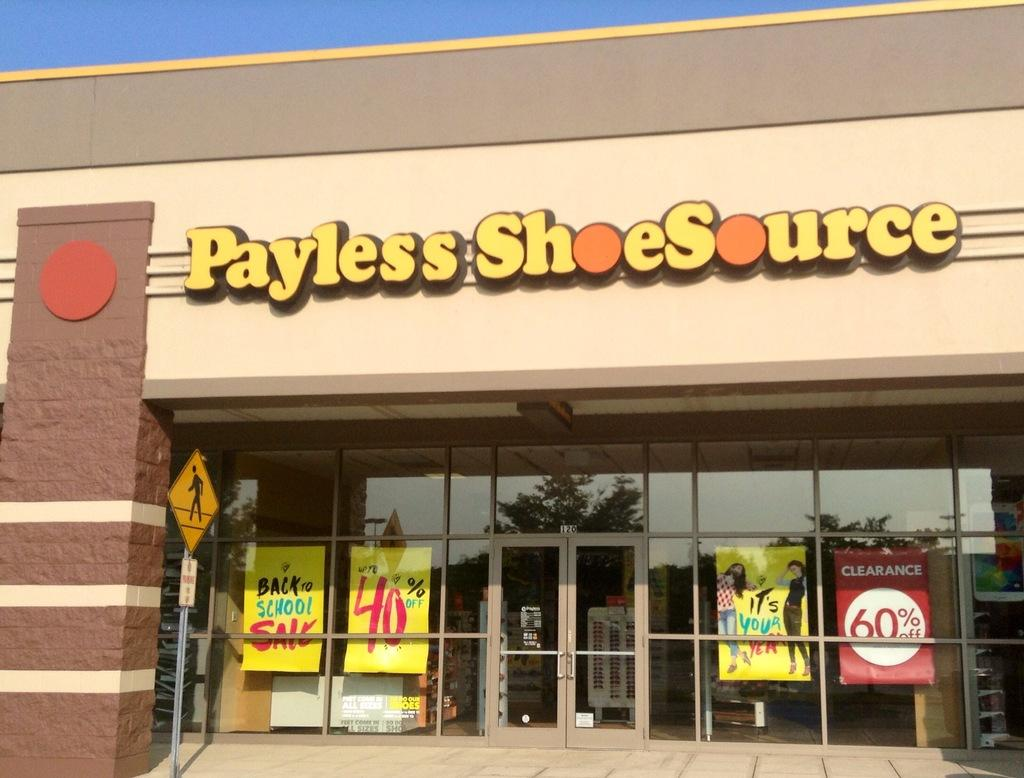What type of establishment is shown in the image? There is a restaurant in the image. What other type of establishment can be seen in the image? There is a store in the image. Where is the sign board located in the image? The sign board is on the left side of the image. What is visible above the sign board? The sky is visible above the sign board. What type of cable is hanging from the sign board in the image? There is no cable hanging from the sign board in the image. What decision was made by the person who designed the store in the image? The image does not provide information about the design decisions made for the store. 